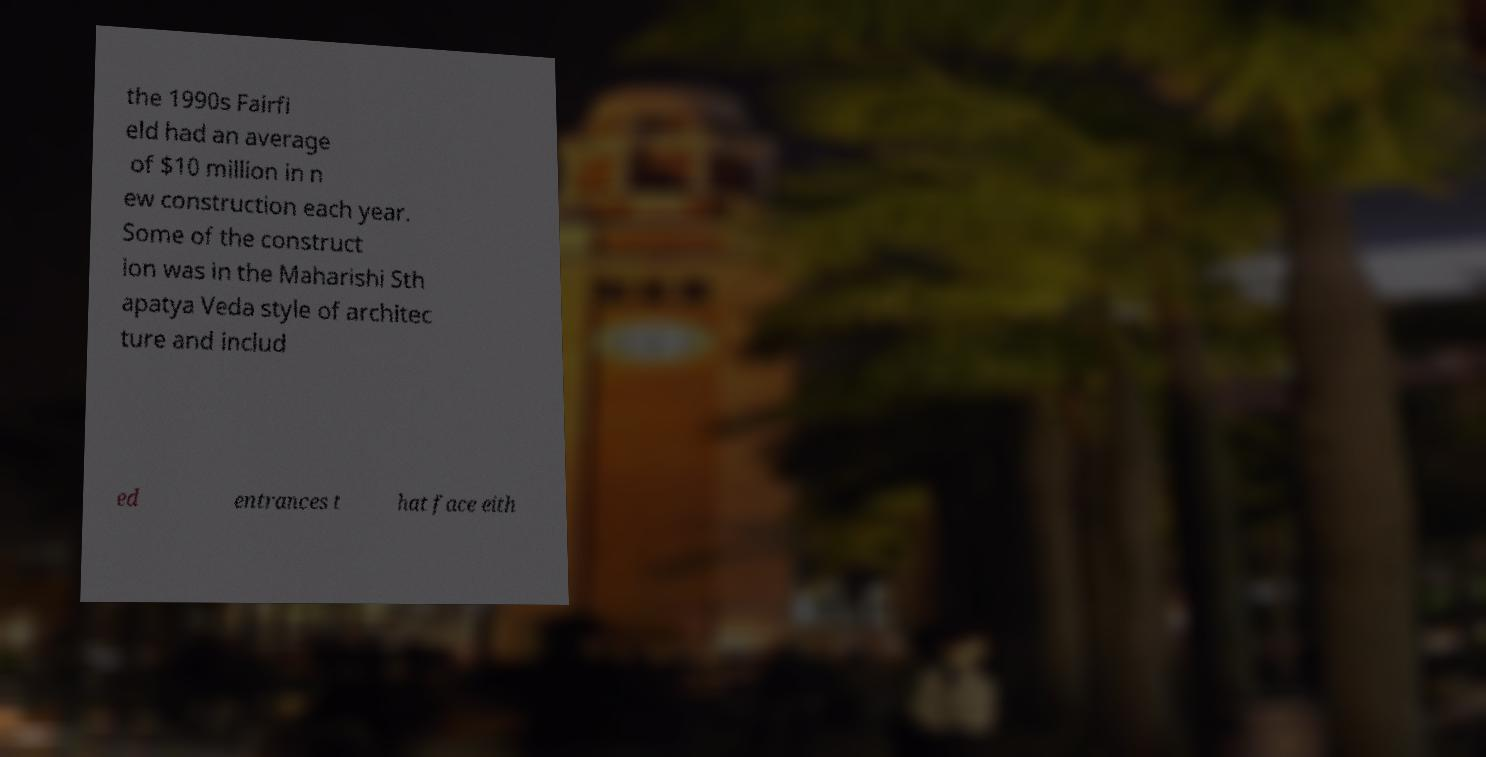Please identify and transcribe the text found in this image. the 1990s Fairfi eld had an average of $10 million in n ew construction each year. Some of the construct ion was in the Maharishi Sth apatya Veda style of architec ture and includ ed entrances t hat face eith 